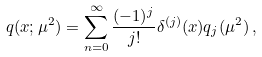<formula> <loc_0><loc_0><loc_500><loc_500>q ( x ; \mu ^ { 2 } ) = \sum _ { n = 0 } ^ { \infty } \frac { ( - 1 ) ^ { j } } { j ! } \delta ^ { ( j ) } ( x ) q _ { j } ( \mu ^ { 2 } ) \, ,</formula> 